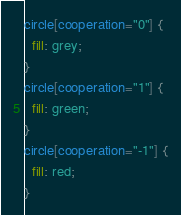Convert code to text. <code><loc_0><loc_0><loc_500><loc_500><_CSS_>circle[cooperation="0"] {
  fill: grey;
}
circle[cooperation="1"] {
  fill: green;
}
circle[cooperation="-1"] {
  fill: red;
}</code> 